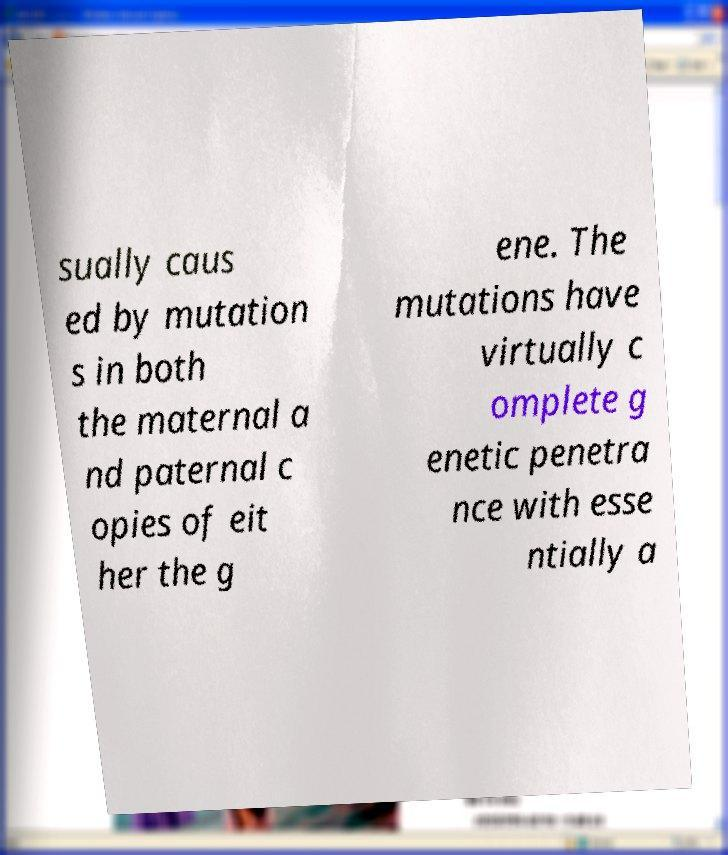What messages or text are displayed in this image? I need them in a readable, typed format. sually caus ed by mutation s in both the maternal a nd paternal c opies of eit her the g ene. The mutations have virtually c omplete g enetic penetra nce with esse ntially a 